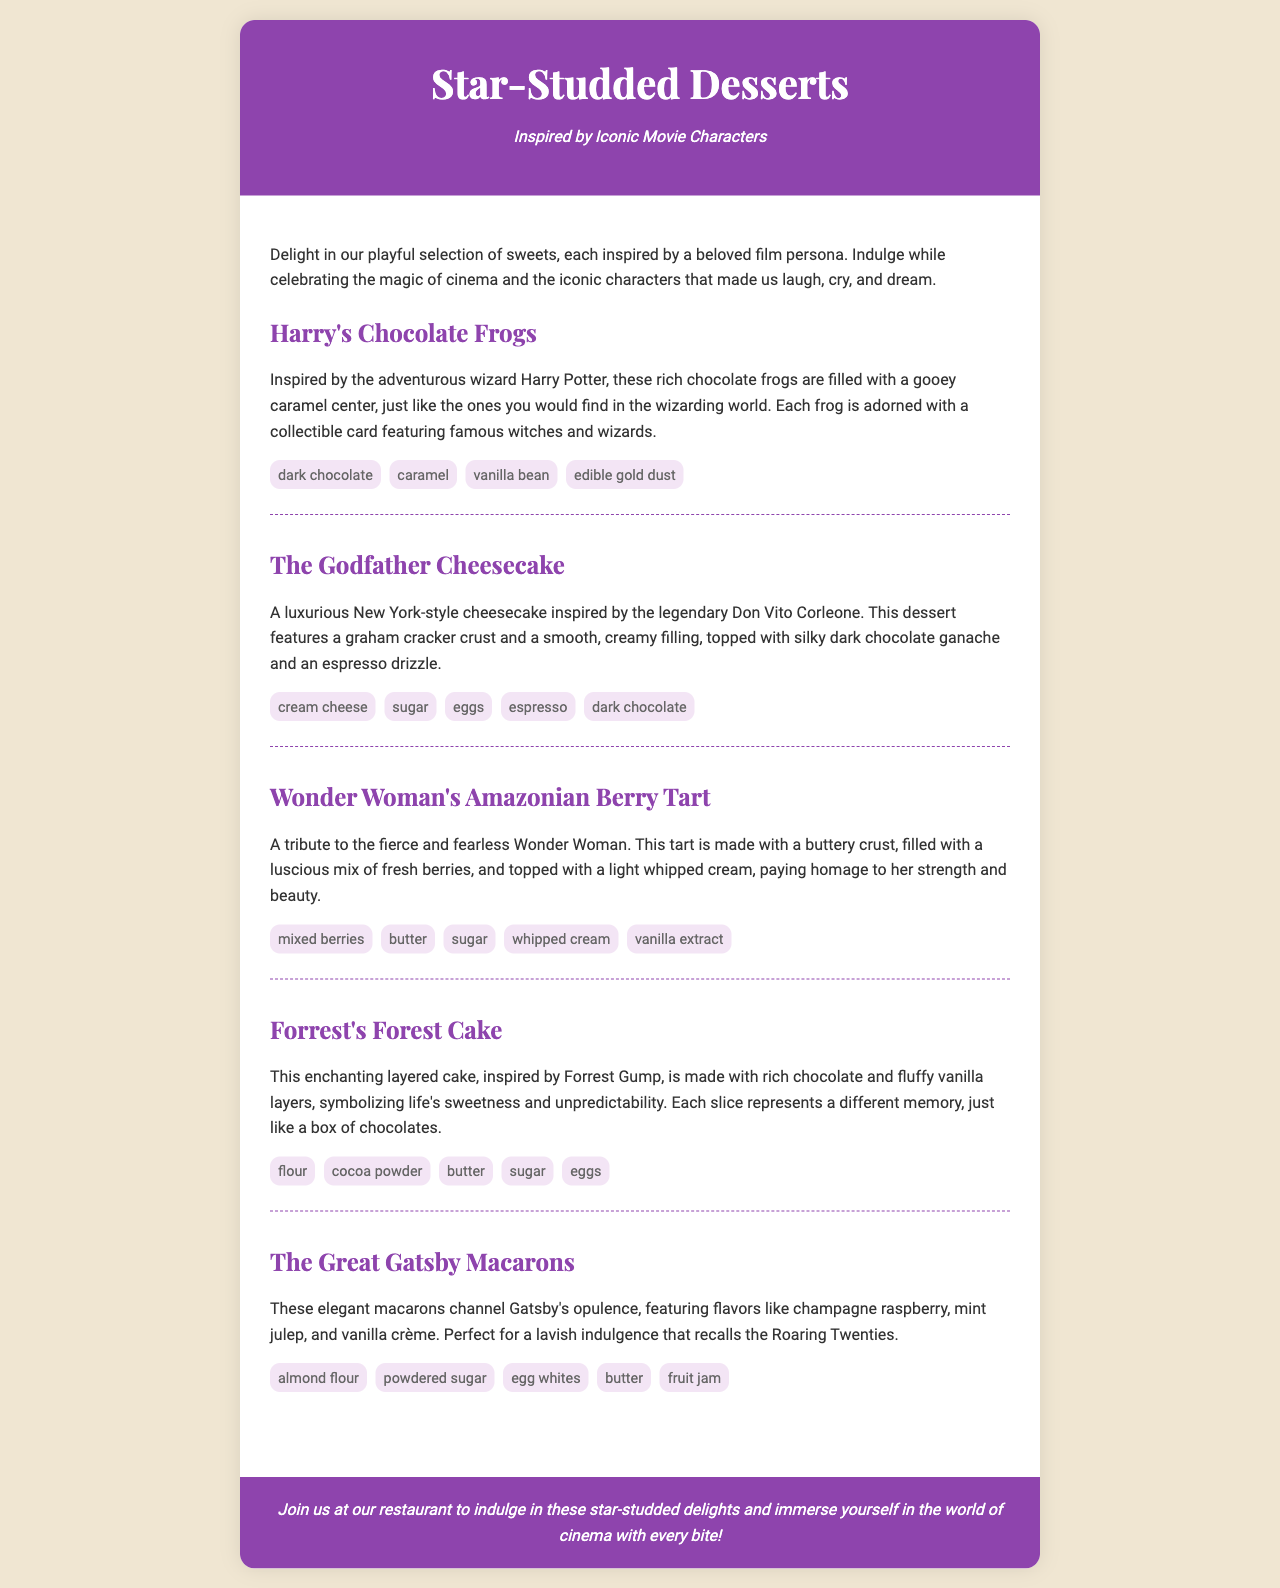what is the first dessert listed? The first dessert in the menu is named "Harry's Chocolate Frogs."
Answer: Harry's Chocolate Frogs how many ingredients are in The Godfather Cheesecake? The Godfather Cheesecake has five ingredients listed.
Answer: 5 which dessert features mixed berries? The dessert that features mixed berries is "Wonder Woman's Amazonian Berry Tart."
Answer: Wonder Woman's Amazonian Berry Tart what is the key ingredient in The Great Gatsby Macarons that reflects opulence? The key ingredient that reflects opulence in The Great Gatsby Macarons is "champagne."
Answer: champagne who is the dessert Forrest's Forest Cake inspired by? Forrest's Forest Cake is inspired by Forrest Gump.
Answer: Forrest Gump 